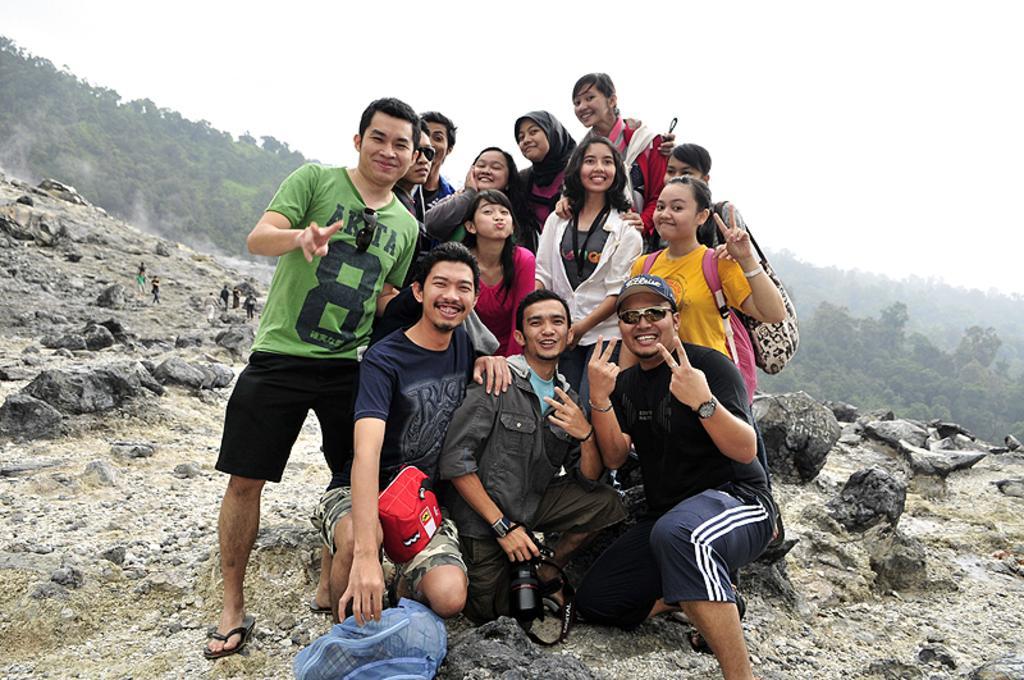Could you give a brief overview of what you see in this image? This picture is taken from outside of the city. In this image, we can see a few people are in squat position and a group of people is standing on the rocks. In the background, we can see a group of people, trees, plants. At the top, we can see a sky, at the bottom, we can see a cover and some stones on the land. 